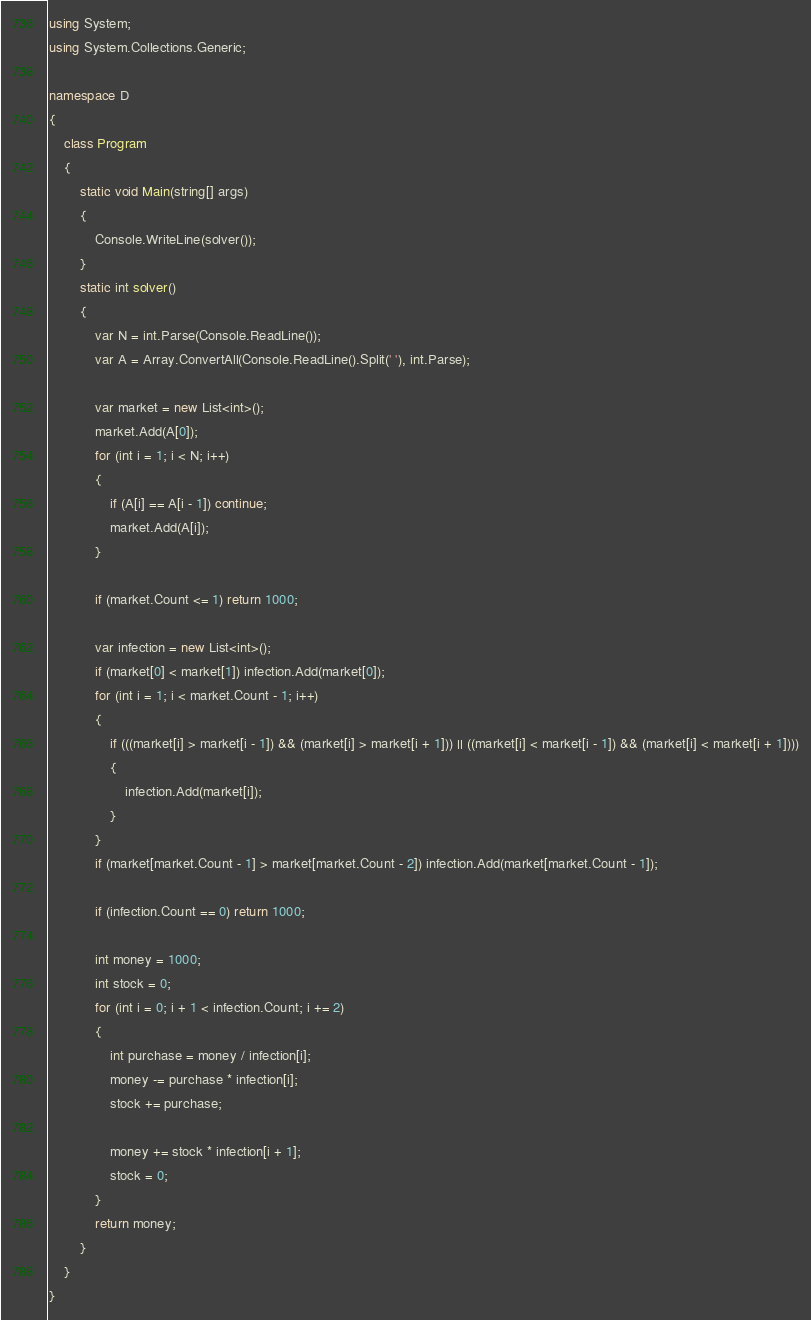Convert code to text. <code><loc_0><loc_0><loc_500><loc_500><_C#_>using System;
using System.Collections.Generic;

namespace D
{
    class Program
    {
        static void Main(string[] args)
        {
            Console.WriteLine(solver());
        }
        static int solver()
        {
            var N = int.Parse(Console.ReadLine());
            var A = Array.ConvertAll(Console.ReadLine().Split(' '), int.Parse);

            var market = new List<int>();
            market.Add(A[0]);
            for (int i = 1; i < N; i++)
            {
                if (A[i] == A[i - 1]) continue;
                market.Add(A[i]);
            }

            if (market.Count <= 1) return 1000;

            var infection = new List<int>();
            if (market[0] < market[1]) infection.Add(market[0]);
            for (int i = 1; i < market.Count - 1; i++)
            {
                if (((market[i] > market[i - 1]) && (market[i] > market[i + 1])) || ((market[i] < market[i - 1]) && (market[i] < market[i + 1])))
                {
                    infection.Add(market[i]);
                }
            }
            if (market[market.Count - 1] > market[market.Count - 2]) infection.Add(market[market.Count - 1]);

            if (infection.Count == 0) return 1000;

            int money = 1000;
            int stock = 0;
            for (int i = 0; i + 1 < infection.Count; i += 2)
            {
                int purchase = money / infection[i];
                money -= purchase * infection[i];
                stock += purchase;

                money += stock * infection[i + 1];
                stock = 0;
            }
            return money;
        }
    }
}
</code> 